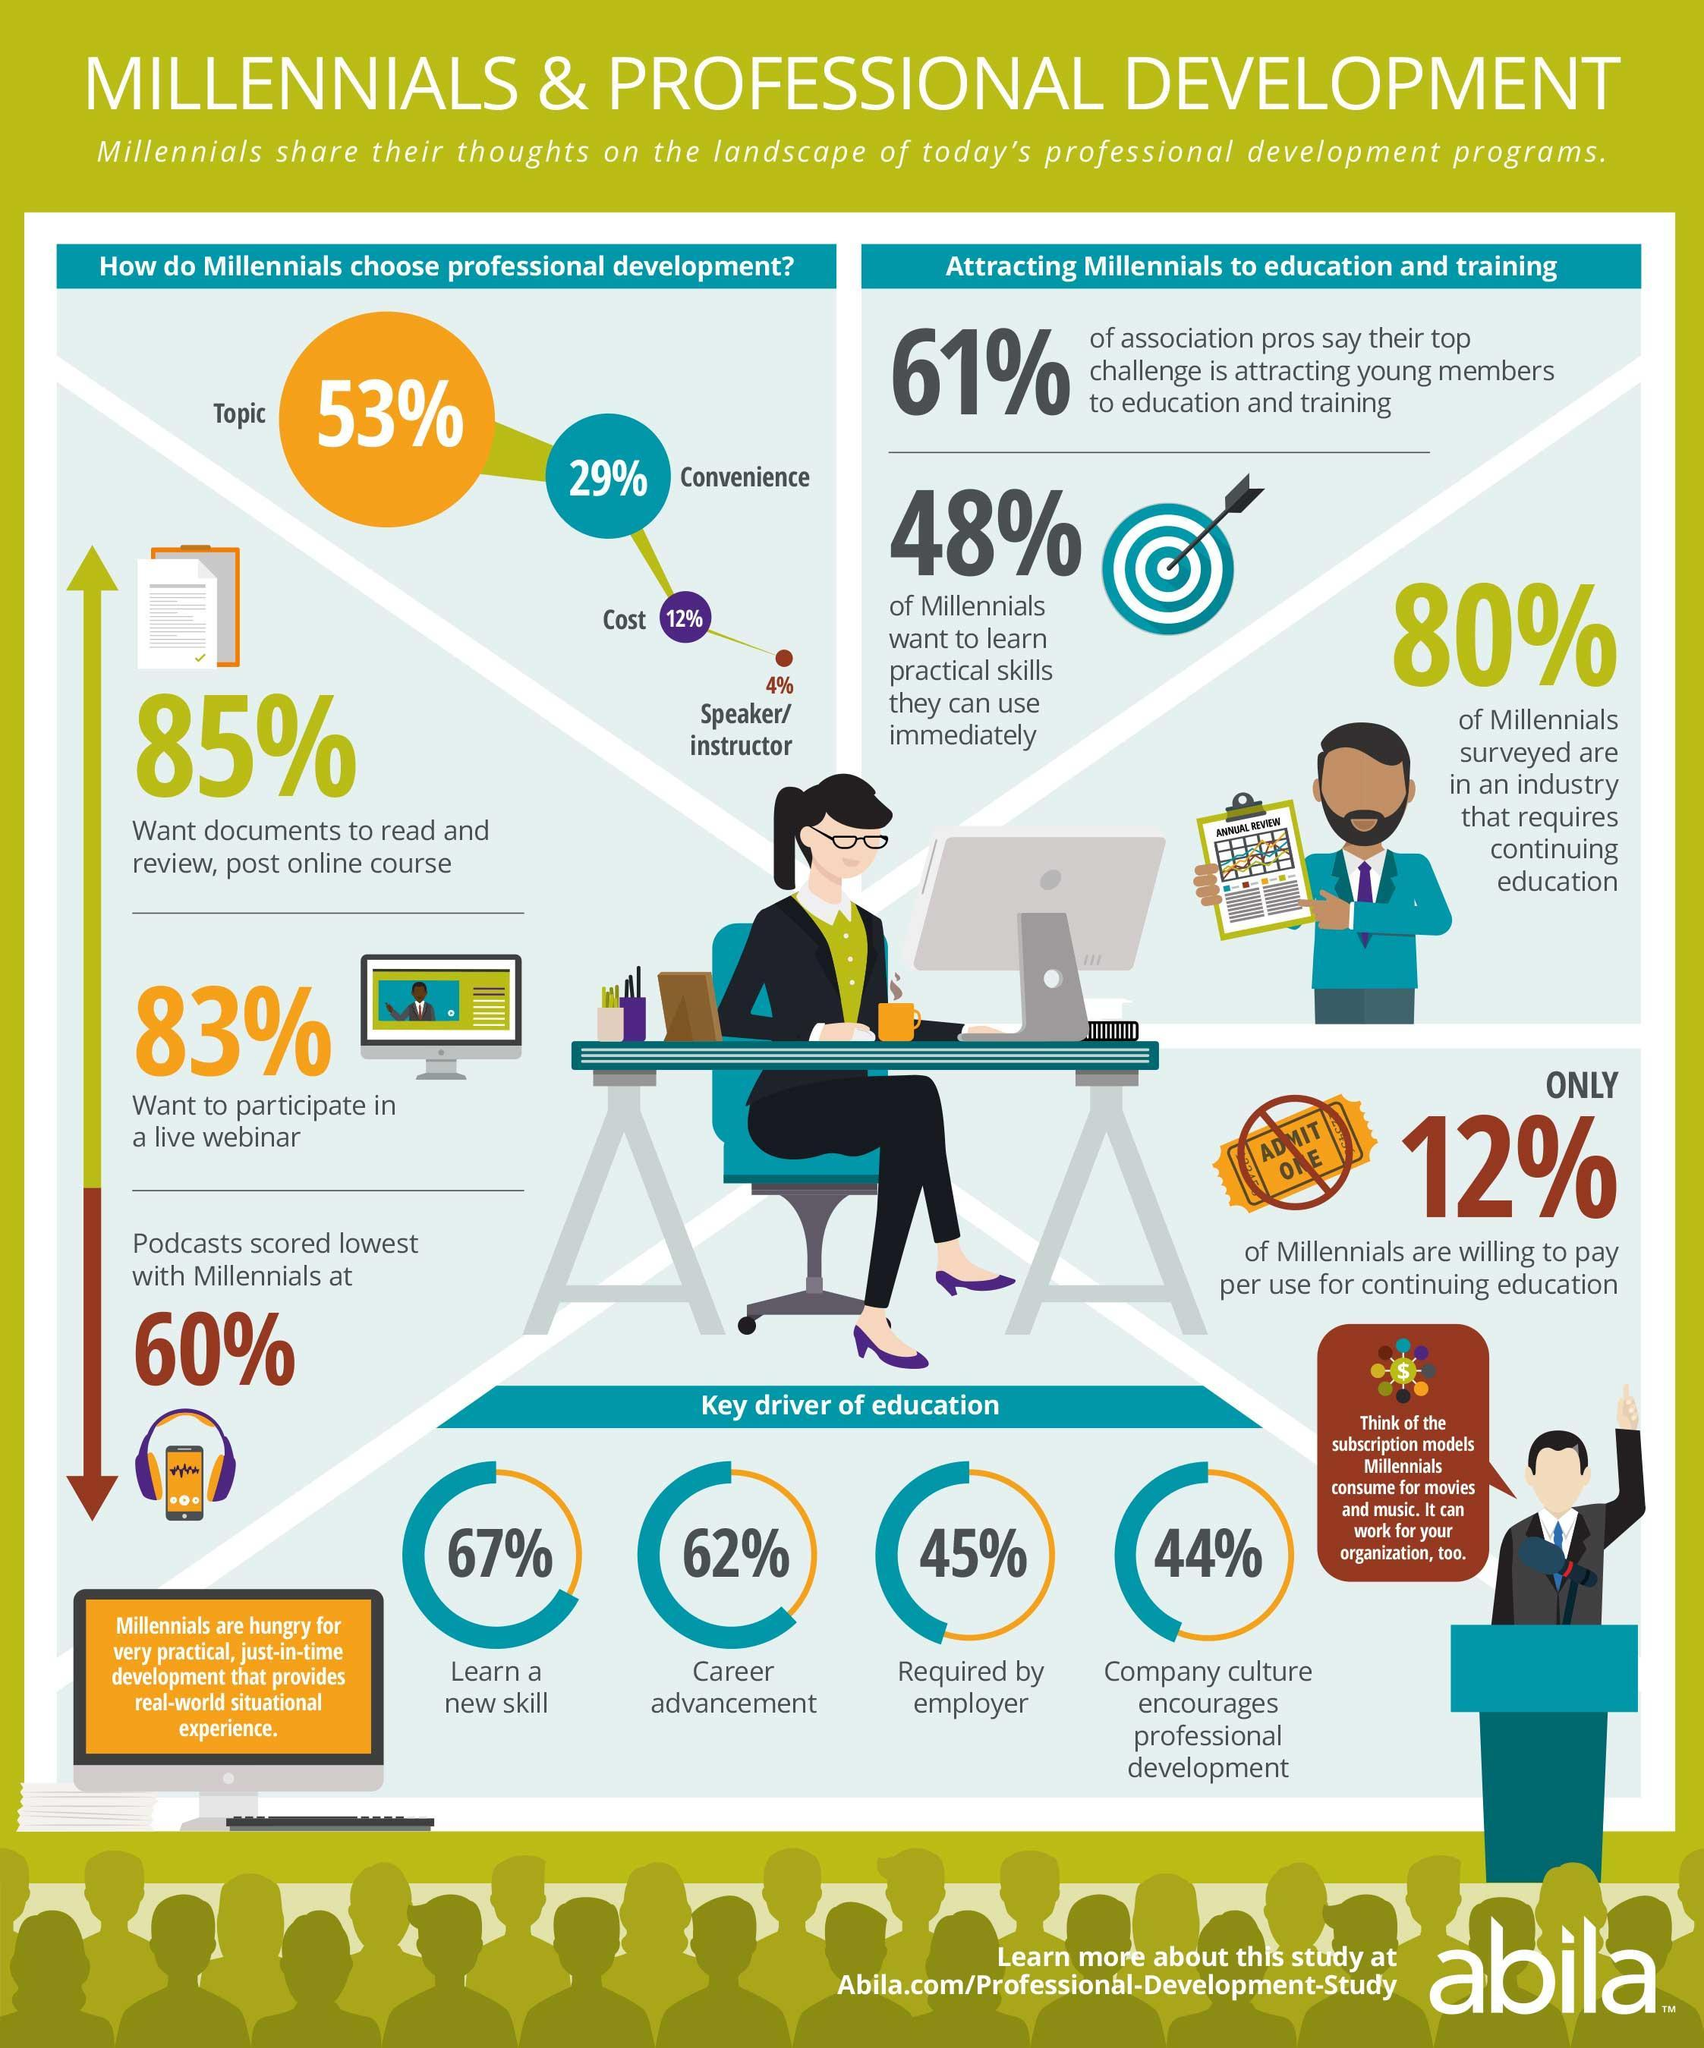What percentage of the millennials use podcasts according to the survey?
Answer the question with a short phrase. 60% What percentage of the millennials are interested in the career advancement as per the survey? 62% What percentage of the millennials wanted to learn a new skill as per the survey? 67% What percentage of millennials do not want to participate in a live webinar as per the survey? 17% What percentage of the millennials are in need of documents to read & review, post online course? 85% What percentage of the millennials are not willing to pay per use for continuing education? 88% 